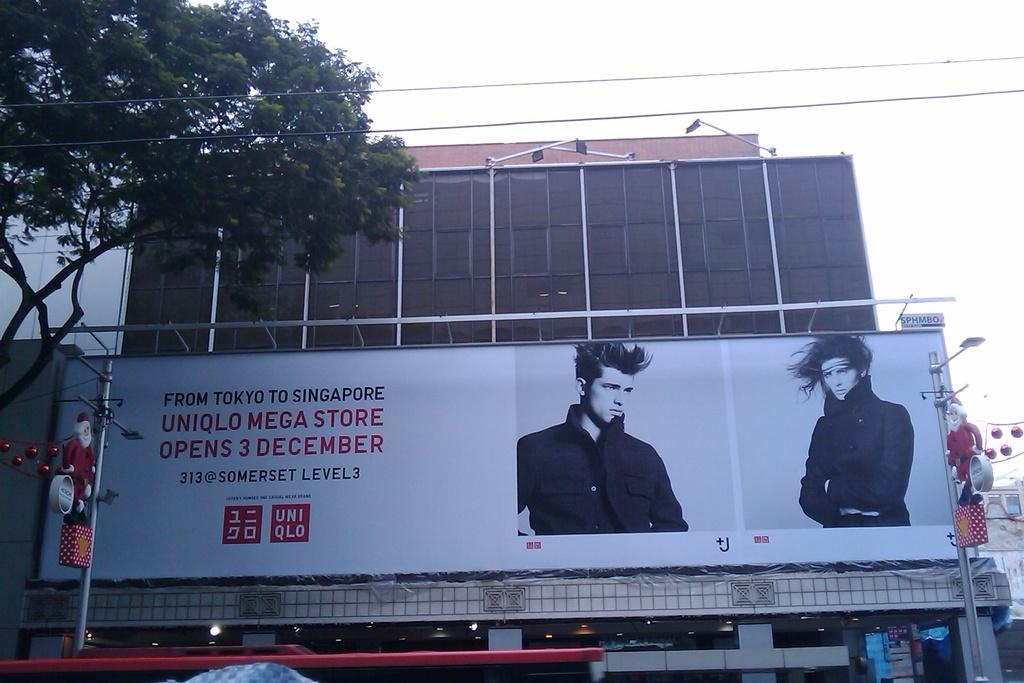<image>
Create a compact narrative representing the image presented. Large white Uniqlo billboard in front of a building. 